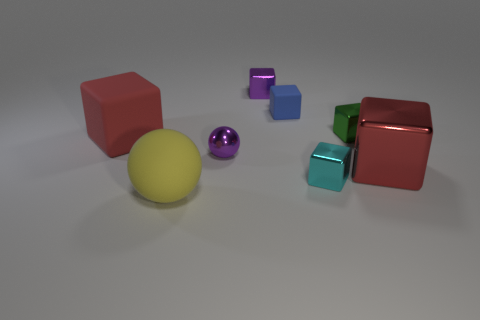Subtract all purple metal blocks. How many blocks are left? 5 Subtract all gray spheres. How many red cubes are left? 2 Subtract all purple cubes. How many cubes are left? 5 Subtract 3 blocks. How many blocks are left? 3 Add 1 gray spheres. How many objects exist? 9 Subtract all purple cubes. Subtract all green cylinders. How many cubes are left? 5 Subtract all blocks. How many objects are left? 2 Add 7 cyan cubes. How many cyan cubes are left? 8 Add 6 large rubber things. How many large rubber things exist? 8 Subtract 0 purple cylinders. How many objects are left? 8 